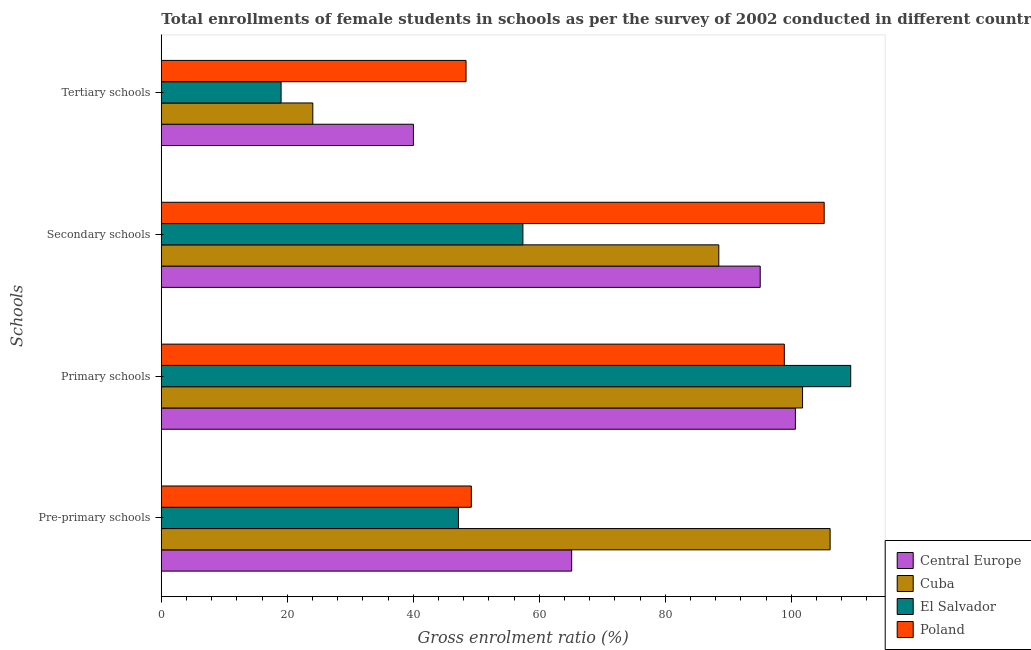How many different coloured bars are there?
Ensure brevity in your answer.  4. How many groups of bars are there?
Make the answer very short. 4. Are the number of bars per tick equal to the number of legend labels?
Keep it short and to the point. Yes. Are the number of bars on each tick of the Y-axis equal?
Your answer should be compact. Yes. How many bars are there on the 4th tick from the top?
Make the answer very short. 4. How many bars are there on the 3rd tick from the bottom?
Offer a very short reply. 4. What is the label of the 3rd group of bars from the top?
Your answer should be compact. Primary schools. What is the gross enrolment ratio(female) in secondary schools in Poland?
Your response must be concise. 105.21. Across all countries, what is the maximum gross enrolment ratio(female) in secondary schools?
Offer a terse response. 105.21. Across all countries, what is the minimum gross enrolment ratio(female) in secondary schools?
Make the answer very short. 57.39. In which country was the gross enrolment ratio(female) in primary schools maximum?
Offer a very short reply. El Salvador. In which country was the gross enrolment ratio(female) in primary schools minimum?
Provide a succinct answer. Poland. What is the total gross enrolment ratio(female) in tertiary schools in the graph?
Offer a very short reply. 131.44. What is the difference between the gross enrolment ratio(female) in secondary schools in Cuba and that in El Salvador?
Give a very brief answer. 31.09. What is the difference between the gross enrolment ratio(female) in pre-primary schools in El Salvador and the gross enrolment ratio(female) in tertiary schools in Central Europe?
Make the answer very short. 7.14. What is the average gross enrolment ratio(female) in primary schools per country?
Your response must be concise. 102.68. What is the difference between the gross enrolment ratio(female) in tertiary schools and gross enrolment ratio(female) in primary schools in Poland?
Your answer should be very brief. -50.52. In how many countries, is the gross enrolment ratio(female) in secondary schools greater than 84 %?
Ensure brevity in your answer.  3. What is the ratio of the gross enrolment ratio(female) in tertiary schools in Cuba to that in El Salvador?
Provide a short and direct response. 1.26. What is the difference between the highest and the second highest gross enrolment ratio(female) in secondary schools?
Keep it short and to the point. 10.15. What is the difference between the highest and the lowest gross enrolment ratio(female) in secondary schools?
Provide a succinct answer. 47.82. Is the sum of the gross enrolment ratio(female) in pre-primary schools in Central Europe and Poland greater than the maximum gross enrolment ratio(female) in secondary schools across all countries?
Offer a very short reply. Yes. Is it the case that in every country, the sum of the gross enrolment ratio(female) in primary schools and gross enrolment ratio(female) in pre-primary schools is greater than the sum of gross enrolment ratio(female) in secondary schools and gross enrolment ratio(female) in tertiary schools?
Provide a succinct answer. Yes. What does the 3rd bar from the top in Secondary schools represents?
Make the answer very short. Cuba. What does the 4th bar from the bottom in Primary schools represents?
Provide a short and direct response. Poland. Is it the case that in every country, the sum of the gross enrolment ratio(female) in pre-primary schools and gross enrolment ratio(female) in primary schools is greater than the gross enrolment ratio(female) in secondary schools?
Provide a short and direct response. Yes. How many bars are there?
Your answer should be very brief. 16. How many countries are there in the graph?
Offer a terse response. 4. Are the values on the major ticks of X-axis written in scientific E-notation?
Make the answer very short. No. Does the graph contain grids?
Your response must be concise. No. Where does the legend appear in the graph?
Keep it short and to the point. Bottom right. What is the title of the graph?
Ensure brevity in your answer.  Total enrollments of female students in schools as per the survey of 2002 conducted in different countries. Does "Malta" appear as one of the legend labels in the graph?
Give a very brief answer. No. What is the label or title of the Y-axis?
Provide a short and direct response. Schools. What is the Gross enrolment ratio (%) of Central Europe in Pre-primary schools?
Ensure brevity in your answer.  65.13. What is the Gross enrolment ratio (%) of Cuba in Pre-primary schools?
Provide a short and direct response. 106.15. What is the Gross enrolment ratio (%) of El Salvador in Pre-primary schools?
Give a very brief answer. 47.16. What is the Gross enrolment ratio (%) of Poland in Pre-primary schools?
Offer a terse response. 49.2. What is the Gross enrolment ratio (%) in Central Europe in Primary schools?
Give a very brief answer. 100.64. What is the Gross enrolment ratio (%) in Cuba in Primary schools?
Give a very brief answer. 101.78. What is the Gross enrolment ratio (%) of El Salvador in Primary schools?
Your answer should be very brief. 109.42. What is the Gross enrolment ratio (%) of Poland in Primary schools?
Provide a short and direct response. 98.88. What is the Gross enrolment ratio (%) of Central Europe in Secondary schools?
Your response must be concise. 95.06. What is the Gross enrolment ratio (%) in Cuba in Secondary schools?
Your answer should be very brief. 88.49. What is the Gross enrolment ratio (%) in El Salvador in Secondary schools?
Provide a short and direct response. 57.39. What is the Gross enrolment ratio (%) of Poland in Secondary schools?
Provide a succinct answer. 105.21. What is the Gross enrolment ratio (%) in Central Europe in Tertiary schools?
Make the answer very short. 40.02. What is the Gross enrolment ratio (%) in Cuba in Tertiary schools?
Offer a very short reply. 24.05. What is the Gross enrolment ratio (%) in El Salvador in Tertiary schools?
Give a very brief answer. 19.01. What is the Gross enrolment ratio (%) in Poland in Tertiary schools?
Provide a short and direct response. 48.37. Across all Schools, what is the maximum Gross enrolment ratio (%) of Central Europe?
Make the answer very short. 100.64. Across all Schools, what is the maximum Gross enrolment ratio (%) in Cuba?
Keep it short and to the point. 106.15. Across all Schools, what is the maximum Gross enrolment ratio (%) of El Salvador?
Provide a succinct answer. 109.42. Across all Schools, what is the maximum Gross enrolment ratio (%) in Poland?
Make the answer very short. 105.21. Across all Schools, what is the minimum Gross enrolment ratio (%) in Central Europe?
Ensure brevity in your answer.  40.02. Across all Schools, what is the minimum Gross enrolment ratio (%) of Cuba?
Give a very brief answer. 24.05. Across all Schools, what is the minimum Gross enrolment ratio (%) of El Salvador?
Your response must be concise. 19.01. Across all Schools, what is the minimum Gross enrolment ratio (%) in Poland?
Provide a short and direct response. 48.37. What is the total Gross enrolment ratio (%) of Central Europe in the graph?
Your answer should be compact. 300.85. What is the total Gross enrolment ratio (%) in Cuba in the graph?
Provide a short and direct response. 320.47. What is the total Gross enrolment ratio (%) of El Salvador in the graph?
Keep it short and to the point. 232.99. What is the total Gross enrolment ratio (%) of Poland in the graph?
Offer a very short reply. 301.67. What is the difference between the Gross enrolment ratio (%) of Central Europe in Pre-primary schools and that in Primary schools?
Offer a very short reply. -35.51. What is the difference between the Gross enrolment ratio (%) of Cuba in Pre-primary schools and that in Primary schools?
Your answer should be very brief. 4.38. What is the difference between the Gross enrolment ratio (%) of El Salvador in Pre-primary schools and that in Primary schools?
Your answer should be very brief. -62.26. What is the difference between the Gross enrolment ratio (%) in Poland in Pre-primary schools and that in Primary schools?
Provide a succinct answer. -49.68. What is the difference between the Gross enrolment ratio (%) in Central Europe in Pre-primary schools and that in Secondary schools?
Provide a succinct answer. -29.93. What is the difference between the Gross enrolment ratio (%) in Cuba in Pre-primary schools and that in Secondary schools?
Your answer should be very brief. 17.67. What is the difference between the Gross enrolment ratio (%) of El Salvador in Pre-primary schools and that in Secondary schools?
Your answer should be very brief. -10.23. What is the difference between the Gross enrolment ratio (%) in Poland in Pre-primary schools and that in Secondary schools?
Make the answer very short. -56.01. What is the difference between the Gross enrolment ratio (%) of Central Europe in Pre-primary schools and that in Tertiary schools?
Offer a terse response. 25.12. What is the difference between the Gross enrolment ratio (%) in Cuba in Pre-primary schools and that in Tertiary schools?
Your response must be concise. 82.11. What is the difference between the Gross enrolment ratio (%) of El Salvador in Pre-primary schools and that in Tertiary schools?
Keep it short and to the point. 28.15. What is the difference between the Gross enrolment ratio (%) of Poland in Pre-primary schools and that in Tertiary schools?
Your answer should be very brief. 0.84. What is the difference between the Gross enrolment ratio (%) of Central Europe in Primary schools and that in Secondary schools?
Make the answer very short. 5.58. What is the difference between the Gross enrolment ratio (%) of Cuba in Primary schools and that in Secondary schools?
Your answer should be compact. 13.29. What is the difference between the Gross enrolment ratio (%) in El Salvador in Primary schools and that in Secondary schools?
Provide a short and direct response. 52.03. What is the difference between the Gross enrolment ratio (%) of Poland in Primary schools and that in Secondary schools?
Make the answer very short. -6.33. What is the difference between the Gross enrolment ratio (%) in Central Europe in Primary schools and that in Tertiary schools?
Provide a succinct answer. 60.63. What is the difference between the Gross enrolment ratio (%) of Cuba in Primary schools and that in Tertiary schools?
Your answer should be very brief. 77.73. What is the difference between the Gross enrolment ratio (%) of El Salvador in Primary schools and that in Tertiary schools?
Your answer should be compact. 90.41. What is the difference between the Gross enrolment ratio (%) of Poland in Primary schools and that in Tertiary schools?
Your answer should be compact. 50.52. What is the difference between the Gross enrolment ratio (%) in Central Europe in Secondary schools and that in Tertiary schools?
Your response must be concise. 55.04. What is the difference between the Gross enrolment ratio (%) of Cuba in Secondary schools and that in Tertiary schools?
Make the answer very short. 64.44. What is the difference between the Gross enrolment ratio (%) in El Salvador in Secondary schools and that in Tertiary schools?
Your answer should be very brief. 38.38. What is the difference between the Gross enrolment ratio (%) in Poland in Secondary schools and that in Tertiary schools?
Offer a terse response. 56.84. What is the difference between the Gross enrolment ratio (%) in Central Europe in Pre-primary schools and the Gross enrolment ratio (%) in Cuba in Primary schools?
Offer a very short reply. -36.65. What is the difference between the Gross enrolment ratio (%) in Central Europe in Pre-primary schools and the Gross enrolment ratio (%) in El Salvador in Primary schools?
Your answer should be very brief. -44.29. What is the difference between the Gross enrolment ratio (%) of Central Europe in Pre-primary schools and the Gross enrolment ratio (%) of Poland in Primary schools?
Provide a short and direct response. -33.75. What is the difference between the Gross enrolment ratio (%) in Cuba in Pre-primary schools and the Gross enrolment ratio (%) in El Salvador in Primary schools?
Your answer should be compact. -3.27. What is the difference between the Gross enrolment ratio (%) of Cuba in Pre-primary schools and the Gross enrolment ratio (%) of Poland in Primary schools?
Your answer should be very brief. 7.27. What is the difference between the Gross enrolment ratio (%) of El Salvador in Pre-primary schools and the Gross enrolment ratio (%) of Poland in Primary schools?
Offer a terse response. -51.73. What is the difference between the Gross enrolment ratio (%) of Central Europe in Pre-primary schools and the Gross enrolment ratio (%) of Cuba in Secondary schools?
Make the answer very short. -23.36. What is the difference between the Gross enrolment ratio (%) of Central Europe in Pre-primary schools and the Gross enrolment ratio (%) of El Salvador in Secondary schools?
Ensure brevity in your answer.  7.74. What is the difference between the Gross enrolment ratio (%) in Central Europe in Pre-primary schools and the Gross enrolment ratio (%) in Poland in Secondary schools?
Offer a very short reply. -40.08. What is the difference between the Gross enrolment ratio (%) of Cuba in Pre-primary schools and the Gross enrolment ratio (%) of El Salvador in Secondary schools?
Your answer should be very brief. 48.76. What is the difference between the Gross enrolment ratio (%) of Cuba in Pre-primary schools and the Gross enrolment ratio (%) of Poland in Secondary schools?
Provide a succinct answer. 0.94. What is the difference between the Gross enrolment ratio (%) in El Salvador in Pre-primary schools and the Gross enrolment ratio (%) in Poland in Secondary schools?
Offer a very short reply. -58.05. What is the difference between the Gross enrolment ratio (%) of Central Europe in Pre-primary schools and the Gross enrolment ratio (%) of Cuba in Tertiary schools?
Your answer should be compact. 41.09. What is the difference between the Gross enrolment ratio (%) in Central Europe in Pre-primary schools and the Gross enrolment ratio (%) in El Salvador in Tertiary schools?
Give a very brief answer. 46.12. What is the difference between the Gross enrolment ratio (%) in Central Europe in Pre-primary schools and the Gross enrolment ratio (%) in Poland in Tertiary schools?
Your answer should be very brief. 16.77. What is the difference between the Gross enrolment ratio (%) in Cuba in Pre-primary schools and the Gross enrolment ratio (%) in El Salvador in Tertiary schools?
Keep it short and to the point. 87.14. What is the difference between the Gross enrolment ratio (%) of Cuba in Pre-primary schools and the Gross enrolment ratio (%) of Poland in Tertiary schools?
Provide a succinct answer. 57.79. What is the difference between the Gross enrolment ratio (%) in El Salvador in Pre-primary schools and the Gross enrolment ratio (%) in Poland in Tertiary schools?
Make the answer very short. -1.21. What is the difference between the Gross enrolment ratio (%) of Central Europe in Primary schools and the Gross enrolment ratio (%) of Cuba in Secondary schools?
Provide a succinct answer. 12.15. What is the difference between the Gross enrolment ratio (%) of Central Europe in Primary schools and the Gross enrolment ratio (%) of El Salvador in Secondary schools?
Offer a very short reply. 43.25. What is the difference between the Gross enrolment ratio (%) of Central Europe in Primary schools and the Gross enrolment ratio (%) of Poland in Secondary schools?
Keep it short and to the point. -4.57. What is the difference between the Gross enrolment ratio (%) of Cuba in Primary schools and the Gross enrolment ratio (%) of El Salvador in Secondary schools?
Give a very brief answer. 44.39. What is the difference between the Gross enrolment ratio (%) in Cuba in Primary schools and the Gross enrolment ratio (%) in Poland in Secondary schools?
Give a very brief answer. -3.43. What is the difference between the Gross enrolment ratio (%) in El Salvador in Primary schools and the Gross enrolment ratio (%) in Poland in Secondary schools?
Your response must be concise. 4.21. What is the difference between the Gross enrolment ratio (%) in Central Europe in Primary schools and the Gross enrolment ratio (%) in Cuba in Tertiary schools?
Provide a short and direct response. 76.6. What is the difference between the Gross enrolment ratio (%) in Central Europe in Primary schools and the Gross enrolment ratio (%) in El Salvador in Tertiary schools?
Your response must be concise. 81.63. What is the difference between the Gross enrolment ratio (%) of Central Europe in Primary schools and the Gross enrolment ratio (%) of Poland in Tertiary schools?
Give a very brief answer. 52.28. What is the difference between the Gross enrolment ratio (%) of Cuba in Primary schools and the Gross enrolment ratio (%) of El Salvador in Tertiary schools?
Provide a succinct answer. 82.77. What is the difference between the Gross enrolment ratio (%) in Cuba in Primary schools and the Gross enrolment ratio (%) in Poland in Tertiary schools?
Provide a succinct answer. 53.41. What is the difference between the Gross enrolment ratio (%) in El Salvador in Primary schools and the Gross enrolment ratio (%) in Poland in Tertiary schools?
Ensure brevity in your answer.  61.06. What is the difference between the Gross enrolment ratio (%) of Central Europe in Secondary schools and the Gross enrolment ratio (%) of Cuba in Tertiary schools?
Provide a succinct answer. 71.01. What is the difference between the Gross enrolment ratio (%) of Central Europe in Secondary schools and the Gross enrolment ratio (%) of El Salvador in Tertiary schools?
Keep it short and to the point. 76.05. What is the difference between the Gross enrolment ratio (%) in Central Europe in Secondary schools and the Gross enrolment ratio (%) in Poland in Tertiary schools?
Make the answer very short. 46.69. What is the difference between the Gross enrolment ratio (%) of Cuba in Secondary schools and the Gross enrolment ratio (%) of El Salvador in Tertiary schools?
Make the answer very short. 69.48. What is the difference between the Gross enrolment ratio (%) in Cuba in Secondary schools and the Gross enrolment ratio (%) in Poland in Tertiary schools?
Keep it short and to the point. 40.12. What is the difference between the Gross enrolment ratio (%) of El Salvador in Secondary schools and the Gross enrolment ratio (%) of Poland in Tertiary schools?
Offer a terse response. 9.03. What is the average Gross enrolment ratio (%) of Central Europe per Schools?
Your answer should be compact. 75.21. What is the average Gross enrolment ratio (%) in Cuba per Schools?
Your response must be concise. 80.12. What is the average Gross enrolment ratio (%) in El Salvador per Schools?
Your response must be concise. 58.25. What is the average Gross enrolment ratio (%) in Poland per Schools?
Offer a very short reply. 75.42. What is the difference between the Gross enrolment ratio (%) in Central Europe and Gross enrolment ratio (%) in Cuba in Pre-primary schools?
Make the answer very short. -41.02. What is the difference between the Gross enrolment ratio (%) in Central Europe and Gross enrolment ratio (%) in El Salvador in Pre-primary schools?
Ensure brevity in your answer.  17.97. What is the difference between the Gross enrolment ratio (%) of Central Europe and Gross enrolment ratio (%) of Poland in Pre-primary schools?
Your answer should be compact. 15.93. What is the difference between the Gross enrolment ratio (%) of Cuba and Gross enrolment ratio (%) of El Salvador in Pre-primary schools?
Make the answer very short. 59. What is the difference between the Gross enrolment ratio (%) of Cuba and Gross enrolment ratio (%) of Poland in Pre-primary schools?
Your answer should be very brief. 56.95. What is the difference between the Gross enrolment ratio (%) in El Salvador and Gross enrolment ratio (%) in Poland in Pre-primary schools?
Keep it short and to the point. -2.04. What is the difference between the Gross enrolment ratio (%) of Central Europe and Gross enrolment ratio (%) of Cuba in Primary schools?
Your response must be concise. -1.14. What is the difference between the Gross enrolment ratio (%) of Central Europe and Gross enrolment ratio (%) of El Salvador in Primary schools?
Give a very brief answer. -8.78. What is the difference between the Gross enrolment ratio (%) in Central Europe and Gross enrolment ratio (%) in Poland in Primary schools?
Provide a short and direct response. 1.76. What is the difference between the Gross enrolment ratio (%) of Cuba and Gross enrolment ratio (%) of El Salvador in Primary schools?
Offer a very short reply. -7.64. What is the difference between the Gross enrolment ratio (%) in Cuba and Gross enrolment ratio (%) in Poland in Primary schools?
Your answer should be compact. 2.89. What is the difference between the Gross enrolment ratio (%) of El Salvador and Gross enrolment ratio (%) of Poland in Primary schools?
Your answer should be compact. 10.54. What is the difference between the Gross enrolment ratio (%) in Central Europe and Gross enrolment ratio (%) in Cuba in Secondary schools?
Provide a succinct answer. 6.57. What is the difference between the Gross enrolment ratio (%) in Central Europe and Gross enrolment ratio (%) in El Salvador in Secondary schools?
Your answer should be compact. 37.67. What is the difference between the Gross enrolment ratio (%) in Central Europe and Gross enrolment ratio (%) in Poland in Secondary schools?
Make the answer very short. -10.15. What is the difference between the Gross enrolment ratio (%) of Cuba and Gross enrolment ratio (%) of El Salvador in Secondary schools?
Offer a very short reply. 31.09. What is the difference between the Gross enrolment ratio (%) in Cuba and Gross enrolment ratio (%) in Poland in Secondary schools?
Your response must be concise. -16.72. What is the difference between the Gross enrolment ratio (%) in El Salvador and Gross enrolment ratio (%) in Poland in Secondary schools?
Your answer should be very brief. -47.82. What is the difference between the Gross enrolment ratio (%) in Central Europe and Gross enrolment ratio (%) in Cuba in Tertiary schools?
Make the answer very short. 15.97. What is the difference between the Gross enrolment ratio (%) in Central Europe and Gross enrolment ratio (%) in El Salvador in Tertiary schools?
Your response must be concise. 21. What is the difference between the Gross enrolment ratio (%) of Central Europe and Gross enrolment ratio (%) of Poland in Tertiary schools?
Keep it short and to the point. -8.35. What is the difference between the Gross enrolment ratio (%) of Cuba and Gross enrolment ratio (%) of El Salvador in Tertiary schools?
Provide a short and direct response. 5.03. What is the difference between the Gross enrolment ratio (%) of Cuba and Gross enrolment ratio (%) of Poland in Tertiary schools?
Offer a terse response. -24.32. What is the difference between the Gross enrolment ratio (%) of El Salvador and Gross enrolment ratio (%) of Poland in Tertiary schools?
Keep it short and to the point. -29.36. What is the ratio of the Gross enrolment ratio (%) of Central Europe in Pre-primary schools to that in Primary schools?
Keep it short and to the point. 0.65. What is the ratio of the Gross enrolment ratio (%) in Cuba in Pre-primary schools to that in Primary schools?
Offer a very short reply. 1.04. What is the ratio of the Gross enrolment ratio (%) of El Salvador in Pre-primary schools to that in Primary schools?
Give a very brief answer. 0.43. What is the ratio of the Gross enrolment ratio (%) of Poland in Pre-primary schools to that in Primary schools?
Provide a short and direct response. 0.5. What is the ratio of the Gross enrolment ratio (%) of Central Europe in Pre-primary schools to that in Secondary schools?
Provide a short and direct response. 0.69. What is the ratio of the Gross enrolment ratio (%) of Cuba in Pre-primary schools to that in Secondary schools?
Provide a succinct answer. 1.2. What is the ratio of the Gross enrolment ratio (%) of El Salvador in Pre-primary schools to that in Secondary schools?
Your answer should be very brief. 0.82. What is the ratio of the Gross enrolment ratio (%) of Poland in Pre-primary schools to that in Secondary schools?
Your response must be concise. 0.47. What is the ratio of the Gross enrolment ratio (%) of Central Europe in Pre-primary schools to that in Tertiary schools?
Your answer should be very brief. 1.63. What is the ratio of the Gross enrolment ratio (%) in Cuba in Pre-primary schools to that in Tertiary schools?
Give a very brief answer. 4.41. What is the ratio of the Gross enrolment ratio (%) in El Salvador in Pre-primary schools to that in Tertiary schools?
Ensure brevity in your answer.  2.48. What is the ratio of the Gross enrolment ratio (%) in Poland in Pre-primary schools to that in Tertiary schools?
Provide a succinct answer. 1.02. What is the ratio of the Gross enrolment ratio (%) in Central Europe in Primary schools to that in Secondary schools?
Your answer should be compact. 1.06. What is the ratio of the Gross enrolment ratio (%) of Cuba in Primary schools to that in Secondary schools?
Your answer should be very brief. 1.15. What is the ratio of the Gross enrolment ratio (%) in El Salvador in Primary schools to that in Secondary schools?
Your answer should be compact. 1.91. What is the ratio of the Gross enrolment ratio (%) in Poland in Primary schools to that in Secondary schools?
Provide a short and direct response. 0.94. What is the ratio of the Gross enrolment ratio (%) in Central Europe in Primary schools to that in Tertiary schools?
Your answer should be very brief. 2.52. What is the ratio of the Gross enrolment ratio (%) of Cuba in Primary schools to that in Tertiary schools?
Offer a very short reply. 4.23. What is the ratio of the Gross enrolment ratio (%) in El Salvador in Primary schools to that in Tertiary schools?
Your answer should be compact. 5.76. What is the ratio of the Gross enrolment ratio (%) in Poland in Primary schools to that in Tertiary schools?
Ensure brevity in your answer.  2.04. What is the ratio of the Gross enrolment ratio (%) in Central Europe in Secondary schools to that in Tertiary schools?
Offer a very short reply. 2.38. What is the ratio of the Gross enrolment ratio (%) in Cuba in Secondary schools to that in Tertiary schools?
Ensure brevity in your answer.  3.68. What is the ratio of the Gross enrolment ratio (%) in El Salvador in Secondary schools to that in Tertiary schools?
Your answer should be very brief. 3.02. What is the ratio of the Gross enrolment ratio (%) in Poland in Secondary schools to that in Tertiary schools?
Make the answer very short. 2.18. What is the difference between the highest and the second highest Gross enrolment ratio (%) in Central Europe?
Your answer should be very brief. 5.58. What is the difference between the highest and the second highest Gross enrolment ratio (%) of Cuba?
Give a very brief answer. 4.38. What is the difference between the highest and the second highest Gross enrolment ratio (%) of El Salvador?
Offer a very short reply. 52.03. What is the difference between the highest and the second highest Gross enrolment ratio (%) in Poland?
Provide a succinct answer. 6.33. What is the difference between the highest and the lowest Gross enrolment ratio (%) of Central Europe?
Your answer should be very brief. 60.63. What is the difference between the highest and the lowest Gross enrolment ratio (%) in Cuba?
Make the answer very short. 82.11. What is the difference between the highest and the lowest Gross enrolment ratio (%) in El Salvador?
Give a very brief answer. 90.41. What is the difference between the highest and the lowest Gross enrolment ratio (%) of Poland?
Your answer should be compact. 56.84. 